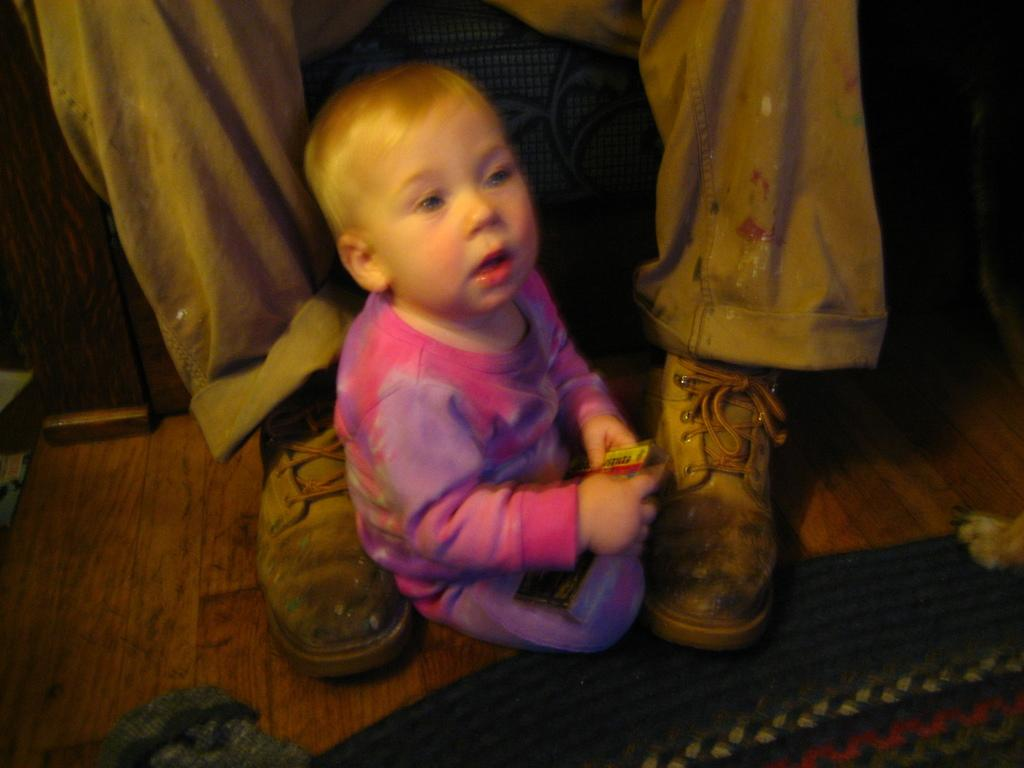What is the main subject of the image? There is a baby in the image. What is the baby doing in the image? The baby is sitting. What is the baby wearing in the image? The baby is wearing a purple and pink dress. Whose legs and shoes are visible in the image? There is a person's legs and shoes visible in the image. What is on the floor in the image? There is a mat on the floor. What color is the floor in the image? The floor is brown in color. How does the baby give approval in the image? The baby does not give approval in the image; there is no indication of approval-giving behavior. 